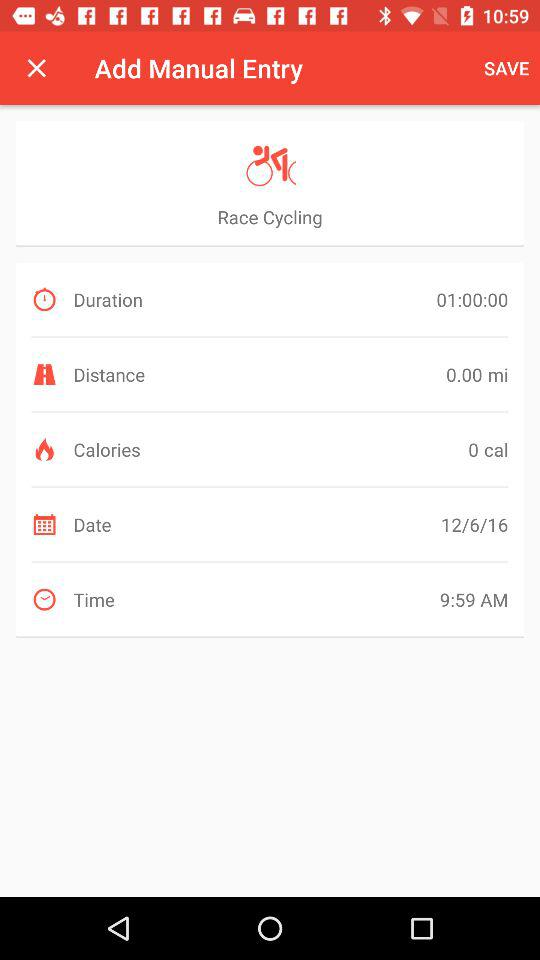How much distance is covered? The distance covered is 0 miles. 